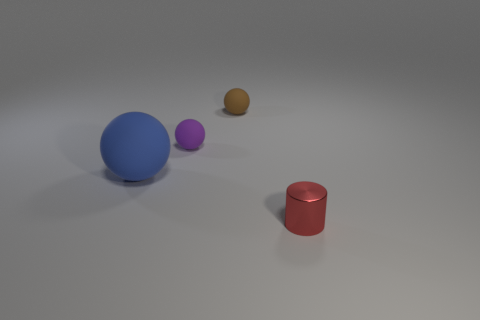Add 2 tiny cylinders. How many objects exist? 6 Subtract all purple matte spheres. How many spheres are left? 2 Subtract all brown spheres. How many spheres are left? 2 Subtract all cylinders. How many objects are left? 3 Subtract 3 balls. How many balls are left? 0 Subtract all big objects. Subtract all brown rubber balls. How many objects are left? 2 Add 4 red cylinders. How many red cylinders are left? 5 Add 1 tiny brown matte spheres. How many tiny brown matte spheres exist? 2 Subtract 0 yellow cylinders. How many objects are left? 4 Subtract all cyan cylinders. Subtract all blue balls. How many cylinders are left? 1 